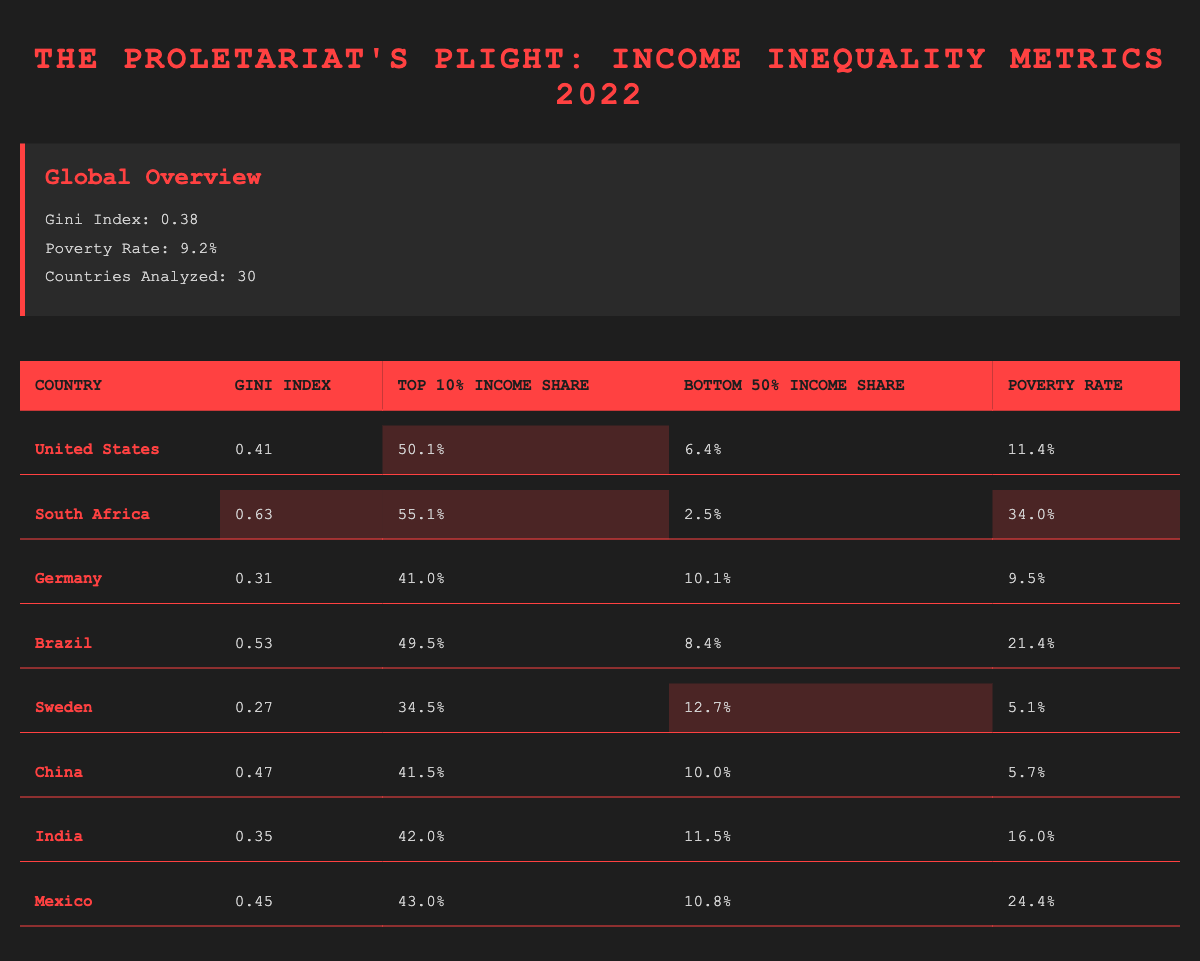What is the Gini Index for South Africa? The Gini Index for South Africa is clearly listed in the table as 0.63.
Answer: 0.63 Which country has the highest Top 10% Income Share? By examining the "Top 10% Income Share" column, South Africa has the highest share at 55.1%.
Answer: 55.1% What is the difference in the Gini Index between Brazil and Germany? The Gini Index for Brazil is 0.53 and for Germany, it is 0.31. The difference is calculated as 0.53 - 0.31 = 0.22.
Answer: 0.22 Is the poverty rate in Sweden lower than that in the United States? The poverty rate in Sweden is 5.1% while in the United States, it is 11.4%. Therefore, yes, Sweden's rate is lower.
Answer: Yes What is the average Gini Index of the countries analyzed? To find the average, sum the Gini Indices of all countries: (0.41 + 0.63 + 0.31 + 0.53 + 0.27 + 0.47 + 0.35 + 0.45) and divide by the number of countries (8). The sum is 3.47; average = 3.47 / 8 ≈ 0.434.
Answer: 0.434 Which country has the lowest poverty rate among the listed countries? Looking at the poverty rates in the table, Sweden has the lowest rate at 5.1%.
Answer: 5.1% If we compare only the Bottom 50% Income Share for all countries, which two countries share the same share? The Bottom 50% Income Share for Germany is 10.1% and for China, it is 10.0%. No two countries share the same share, thus the answer is none.
Answer: None Is India's Top 10% Income Share greater than Mexico's? India's Top 10% Income Share is 42.0% while Mexico’s is 43.0%. Therefore, India's share is not greater than Mexico's.
Answer: No What percentage of income does the Bottom 50% share in South Africa? According to the table, South Africa's Bottom 50% Income Share is 2.5%.
Answer: 2.5% 